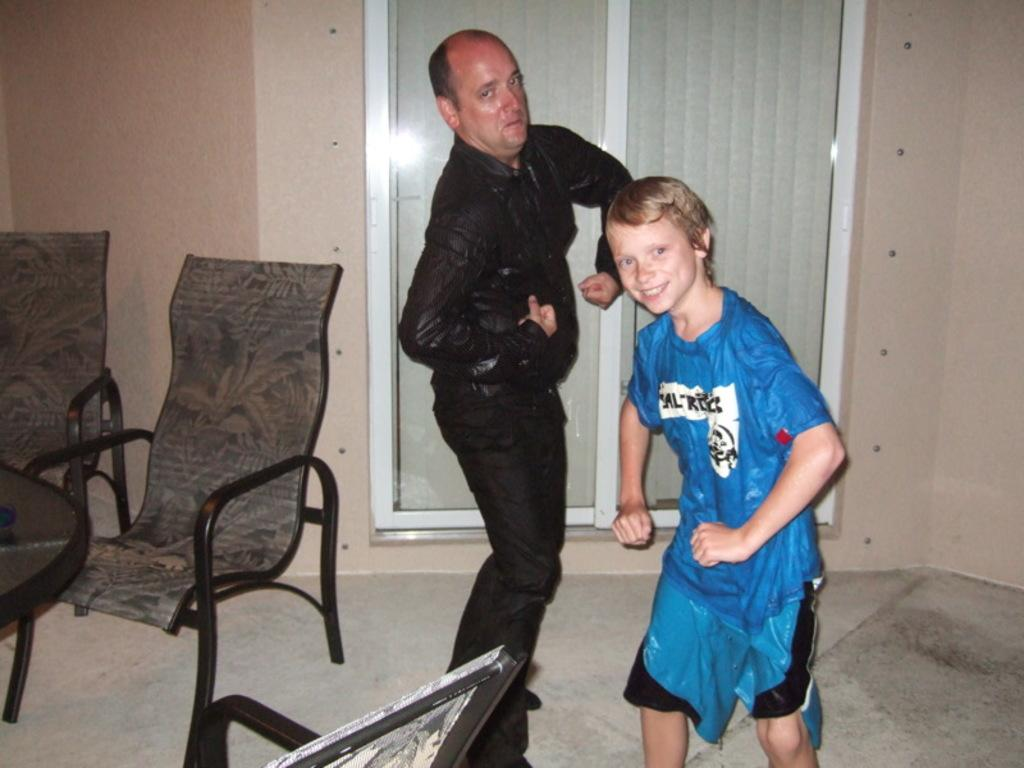Who is present in the image? There is a man and a boy in the image. What can be observed about their clothing? Both the man and the boy are wearing wet clothes. What can be seen on the left side of the image? There is a table and chairs on the left side of the image. What type of gun is the man holding in the image? There is no gun present in the image; the man and the boy are wearing wet clothes and standing near a table and chairs. 